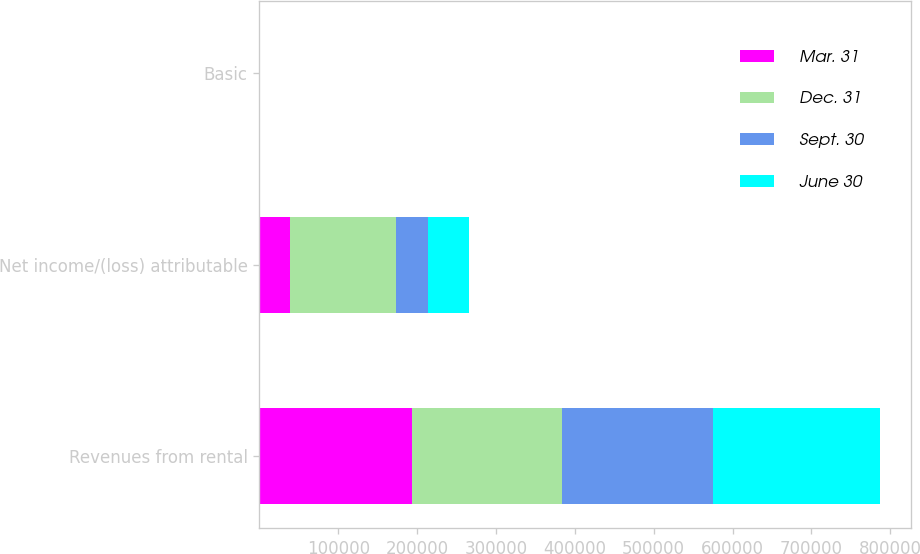Convert chart to OTSL. <chart><loc_0><loc_0><loc_500><loc_500><stacked_bar_chart><ecel><fcel>Revenues from rental<fcel>Net income/(loss) attributable<fcel>Basic<nl><fcel>Mar. 31<fcel>193895<fcel>38424<fcel>0.1<nl><fcel>Dec. 31<fcel>189285<fcel>134651<fcel>0.4<nl><fcel>Sept. 30<fcel>191885<fcel>40108<fcel>0.07<nl><fcel>June 30<fcel>211822<fcel>52177<fcel>0.11<nl></chart> 